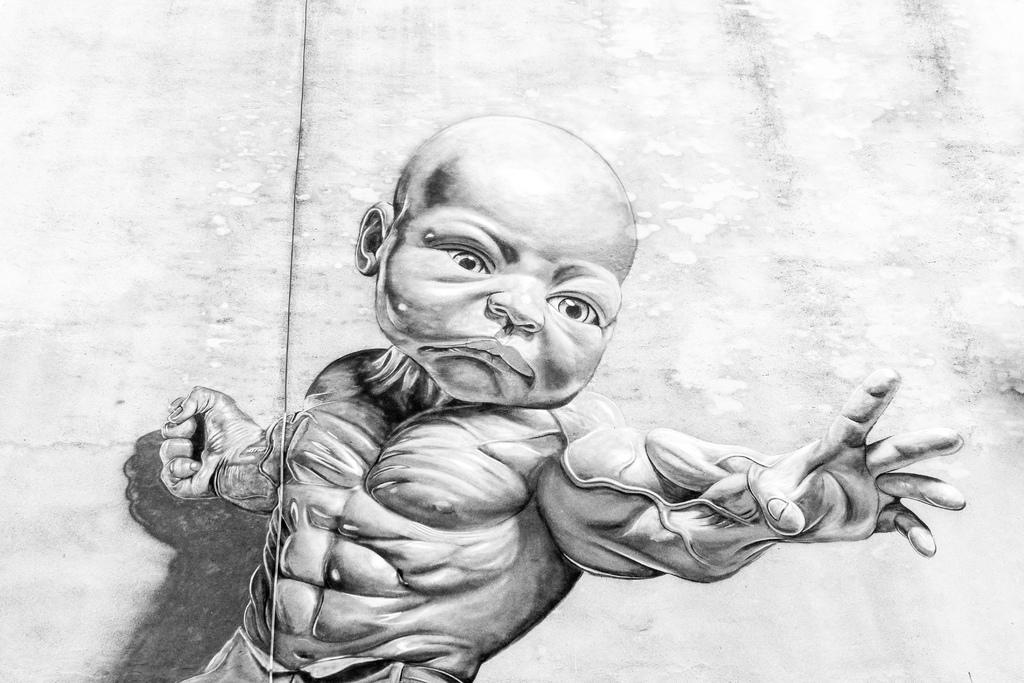What is depicted in the image? There is a sketch of a person's body in the image with a baby's face attached to it. What can be seen in the background of the image? There is a wall in the background of the image. What type of wave can be seen crashing on the shore in the image? There is no wave present in the image; it features a sketch of a person's body with a baby's face and a wall in the background. 